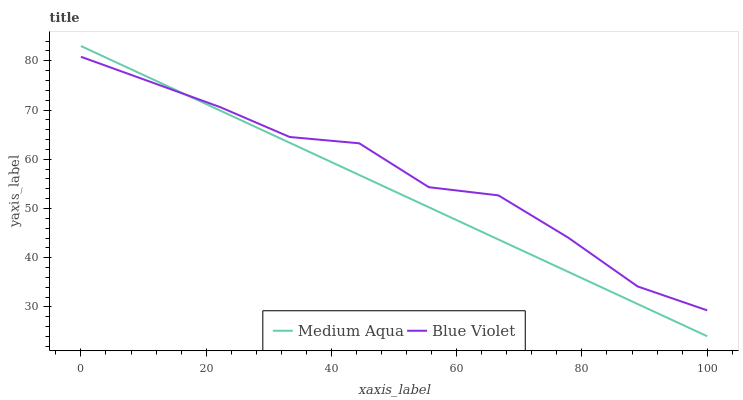Does Medium Aqua have the minimum area under the curve?
Answer yes or no. Yes. Does Blue Violet have the maximum area under the curve?
Answer yes or no. Yes. Does Blue Violet have the minimum area under the curve?
Answer yes or no. No. Is Medium Aqua the smoothest?
Answer yes or no. Yes. Is Blue Violet the roughest?
Answer yes or no. Yes. Is Blue Violet the smoothest?
Answer yes or no. No. Does Medium Aqua have the lowest value?
Answer yes or no. Yes. Does Blue Violet have the lowest value?
Answer yes or no. No. Does Medium Aqua have the highest value?
Answer yes or no. Yes. Does Blue Violet have the highest value?
Answer yes or no. No. Does Medium Aqua intersect Blue Violet?
Answer yes or no. Yes. Is Medium Aqua less than Blue Violet?
Answer yes or no. No. Is Medium Aqua greater than Blue Violet?
Answer yes or no. No. 